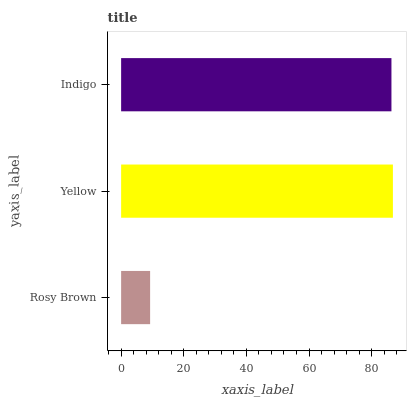Is Rosy Brown the minimum?
Answer yes or no. Yes. Is Yellow the maximum?
Answer yes or no. Yes. Is Indigo the minimum?
Answer yes or no. No. Is Indigo the maximum?
Answer yes or no. No. Is Yellow greater than Indigo?
Answer yes or no. Yes. Is Indigo less than Yellow?
Answer yes or no. Yes. Is Indigo greater than Yellow?
Answer yes or no. No. Is Yellow less than Indigo?
Answer yes or no. No. Is Indigo the high median?
Answer yes or no. Yes. Is Indigo the low median?
Answer yes or no. Yes. Is Rosy Brown the high median?
Answer yes or no. No. Is Yellow the low median?
Answer yes or no. No. 